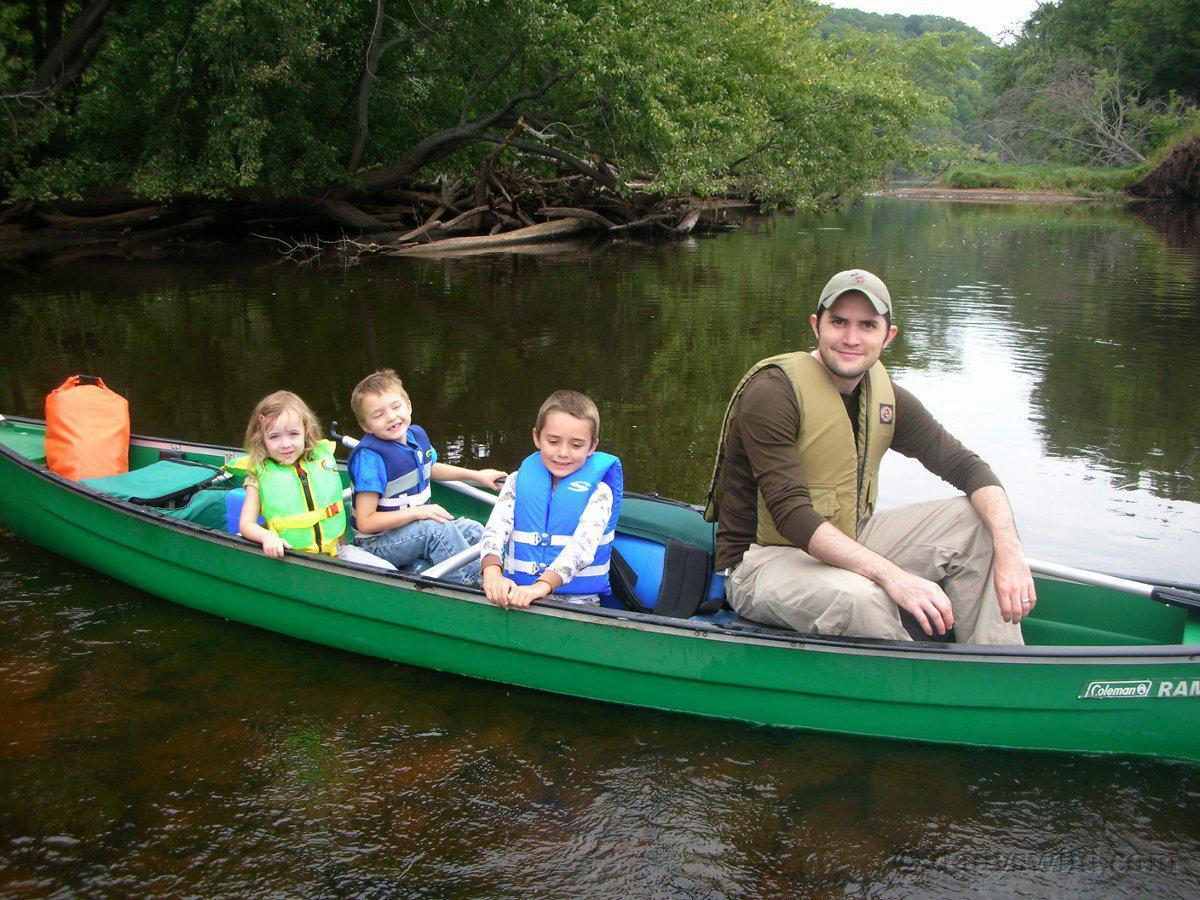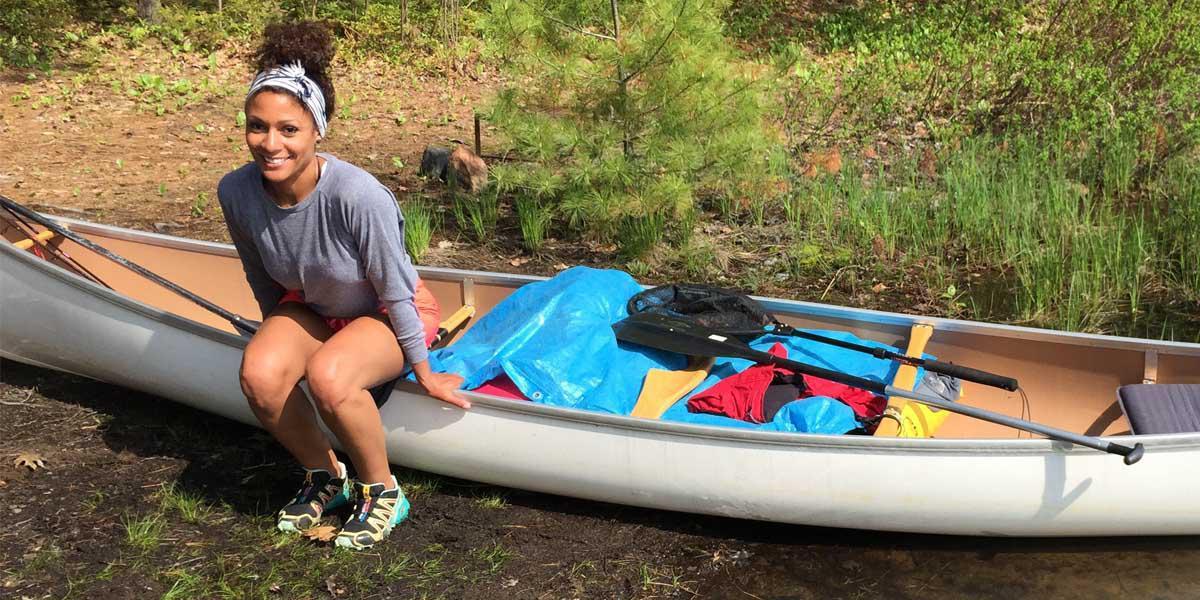The first image is the image on the left, the second image is the image on the right. Examine the images to the left and right. Is the description "There are exactly two canoes in the water." accurate? Answer yes or no. No. The first image is the image on the left, the second image is the image on the right. Examine the images to the left and right. Is the description "The left and right image contains the same number of boats facing left and forward." accurate? Answer yes or no. Yes. 